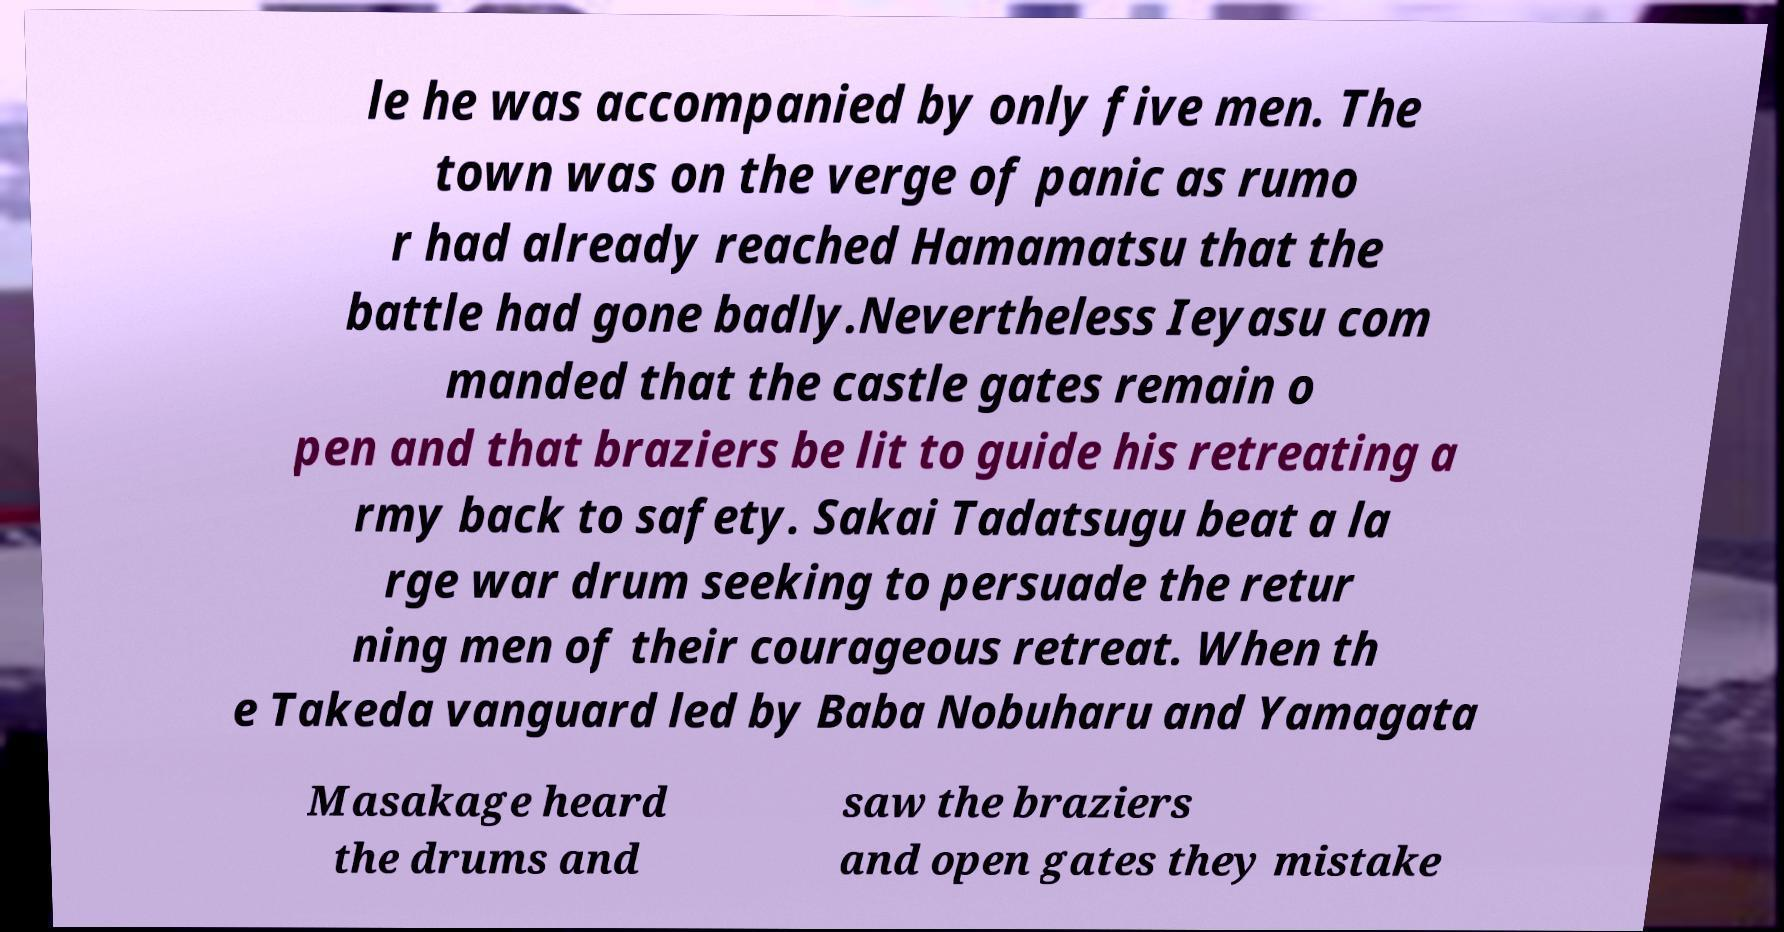Could you extract and type out the text from this image? le he was accompanied by only five men. The town was on the verge of panic as rumo r had already reached Hamamatsu that the battle had gone badly.Nevertheless Ieyasu com manded that the castle gates remain o pen and that braziers be lit to guide his retreating a rmy back to safety. Sakai Tadatsugu beat a la rge war drum seeking to persuade the retur ning men of their courageous retreat. When th e Takeda vanguard led by Baba Nobuharu and Yamagata Masakage heard the drums and saw the braziers and open gates they mistake 